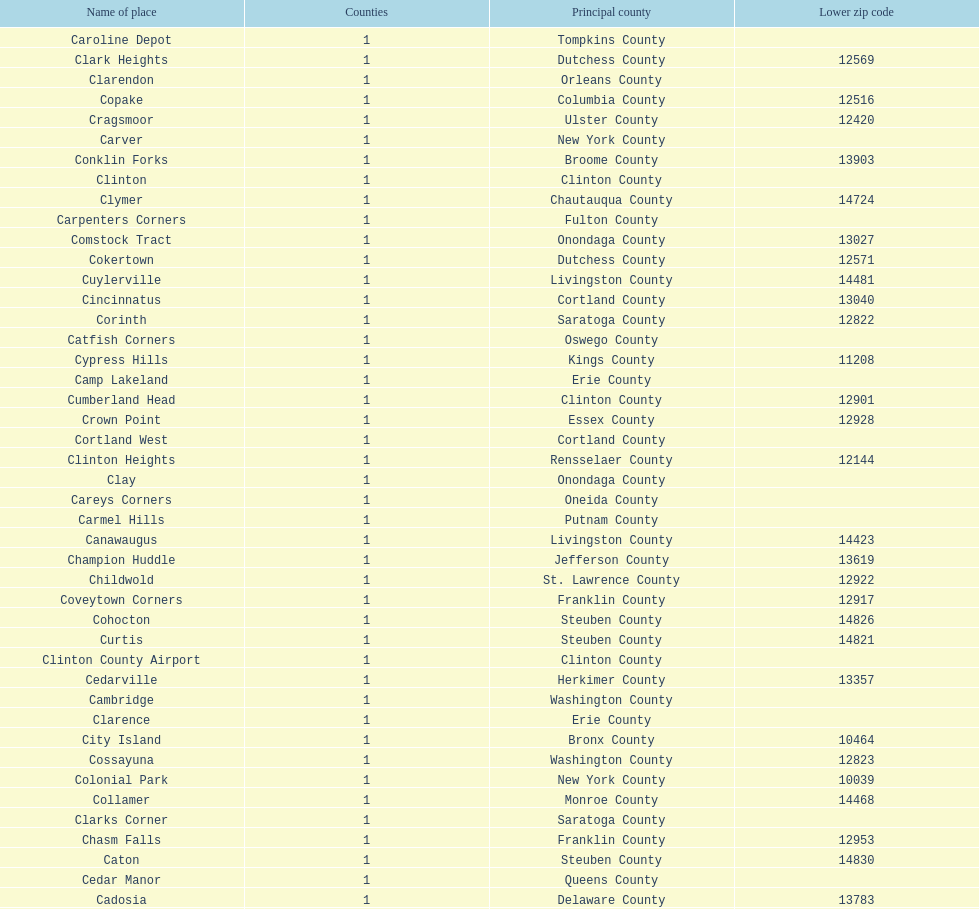How many total places are in greene county? 10. 